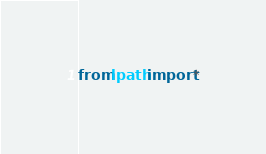Convert code to text. <code><loc_0><loc_0><loc_500><loc_500><_Python_>from lpath import *
</code> 